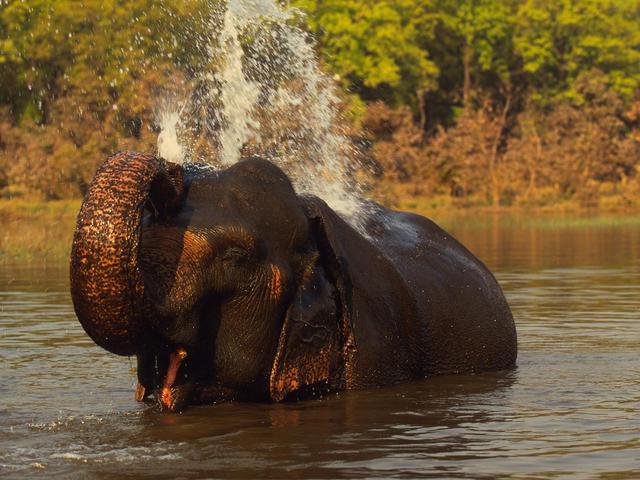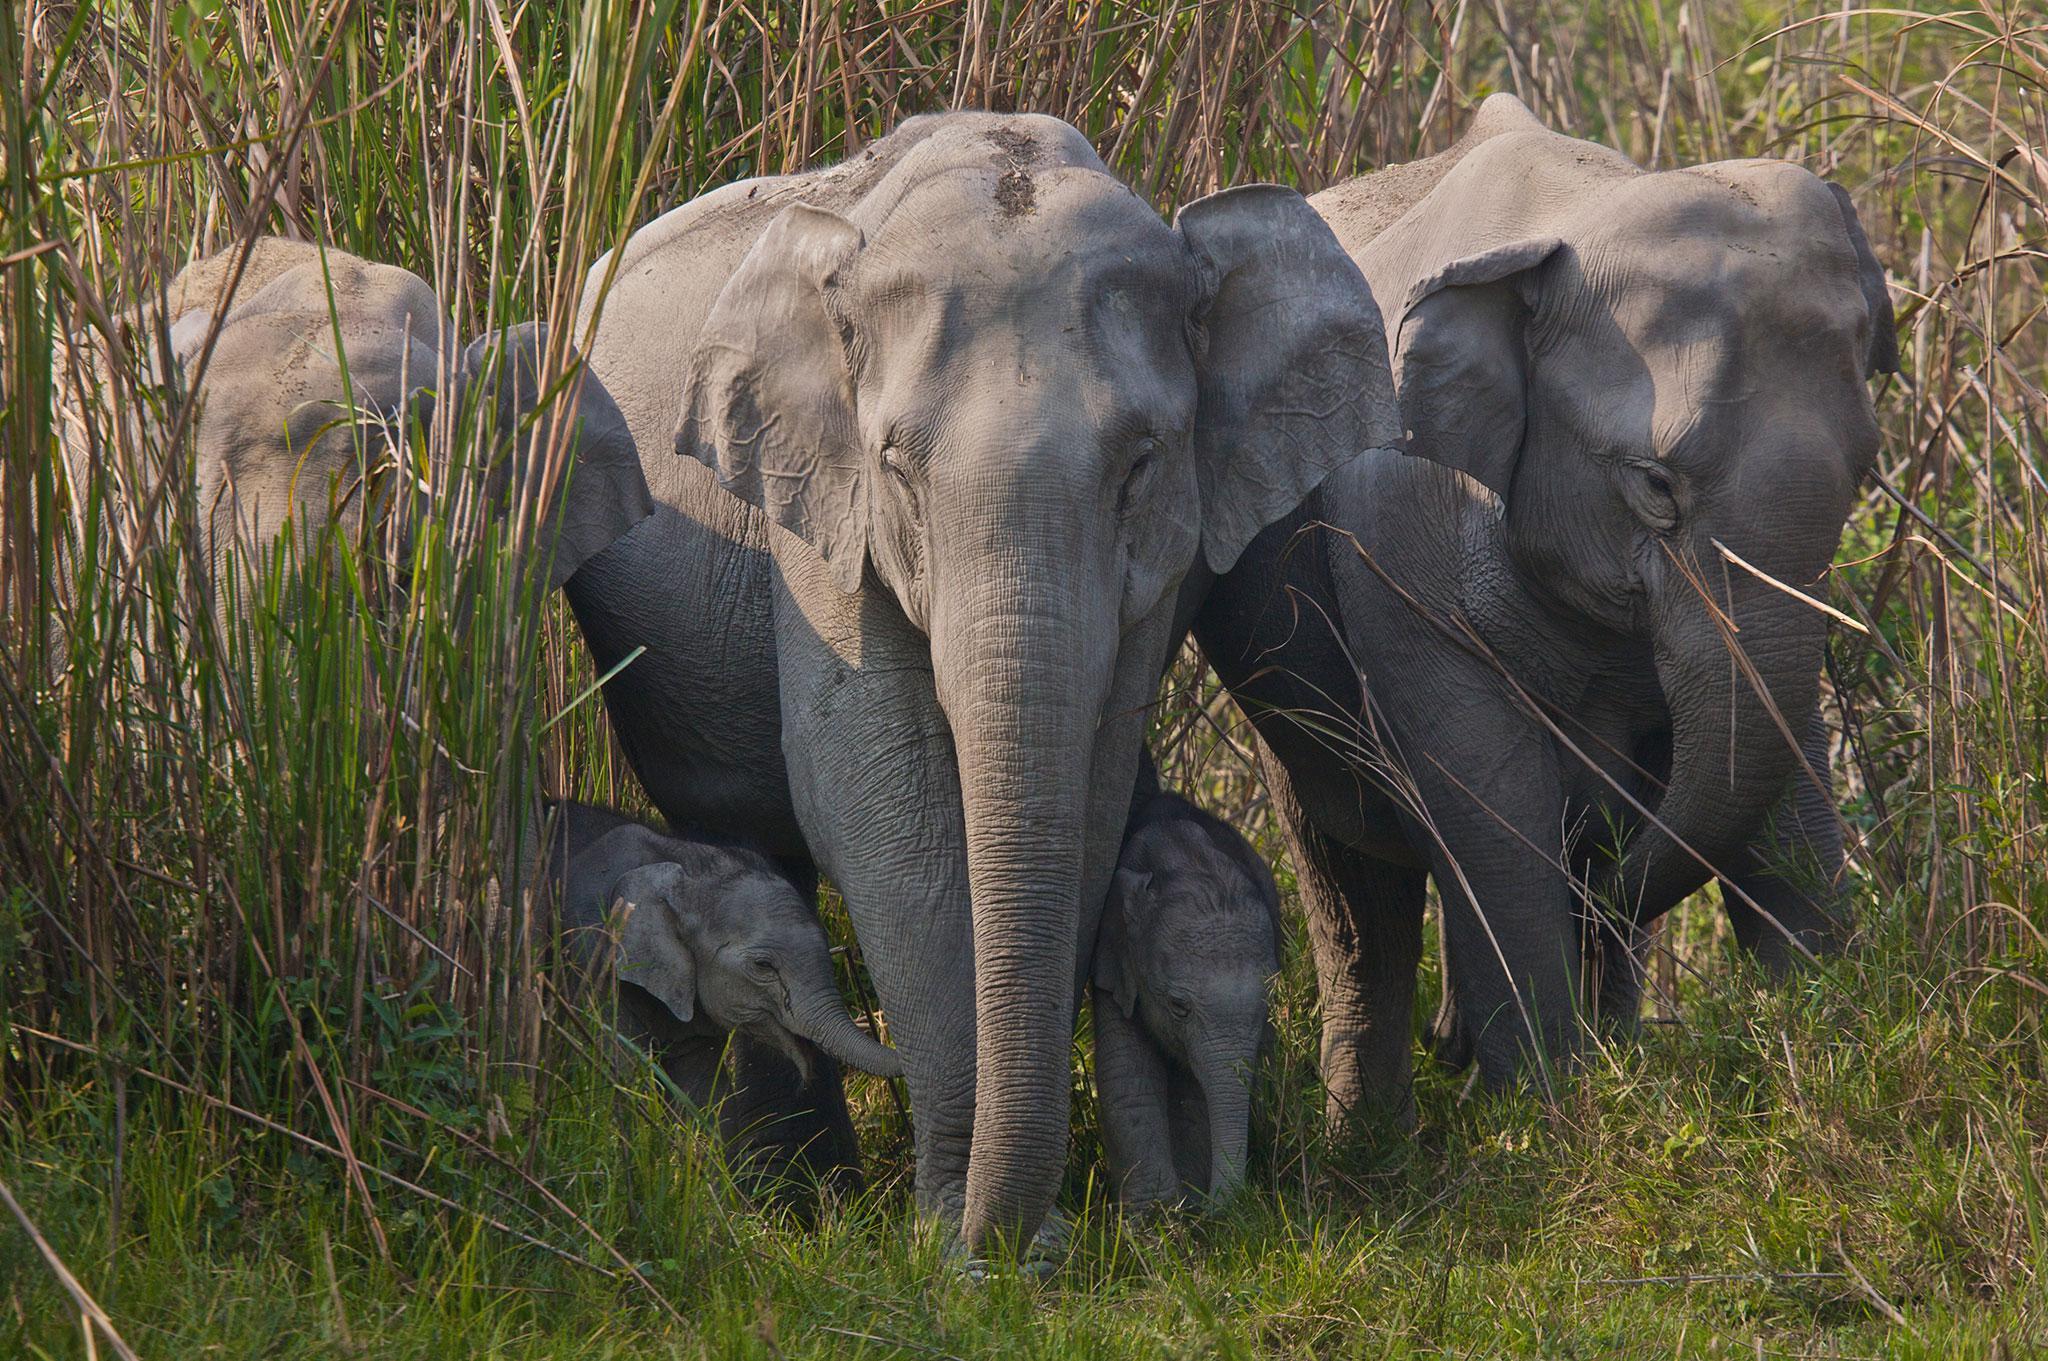The first image is the image on the left, the second image is the image on the right. For the images displayed, is the sentence "There are more animals in the image on the right." factually correct? Answer yes or no. Yes. 